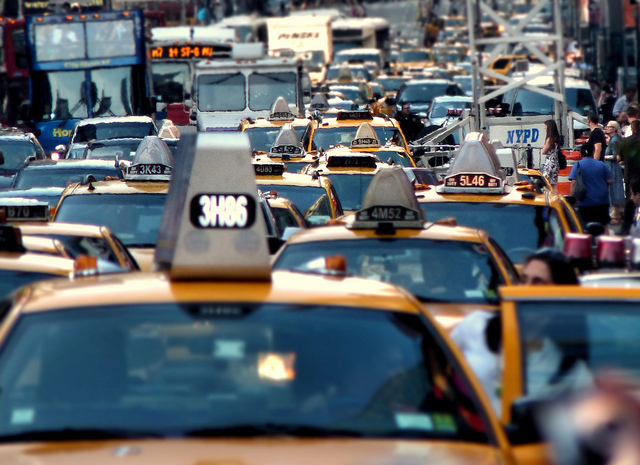Please transcribe the text information in this image. 3H86 NYPD 5L46 3K43 4M52 HOT 870 4009 